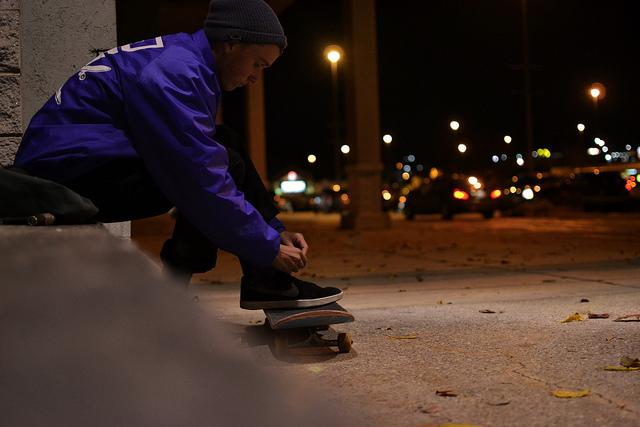What color is the jacket?
Be succinct. Blue. Is it daytime?
Short answer required. No. What is this kid doing?
Keep it brief. Tying shoes. What color are the man's pants?
Write a very short answer. Black. Is it daytime or nighttime?
Give a very brief answer. Night. How many street lights are there?
Concise answer only. Many. How many wheels are on the skateboard?
Quick response, please. 4. Is this happening at sunset?
Write a very short answer. No. What are they sitting on?
Be succinct. Steps. What color are the street lights?
Short answer required. Yellow. What color are the shoes?
Be succinct. Black. Are there leaves laying around?
Short answer required. Yes. What is the person resting their feet on?
Write a very short answer. Skateboard. Is it a sunny day?
Write a very short answer. No. 